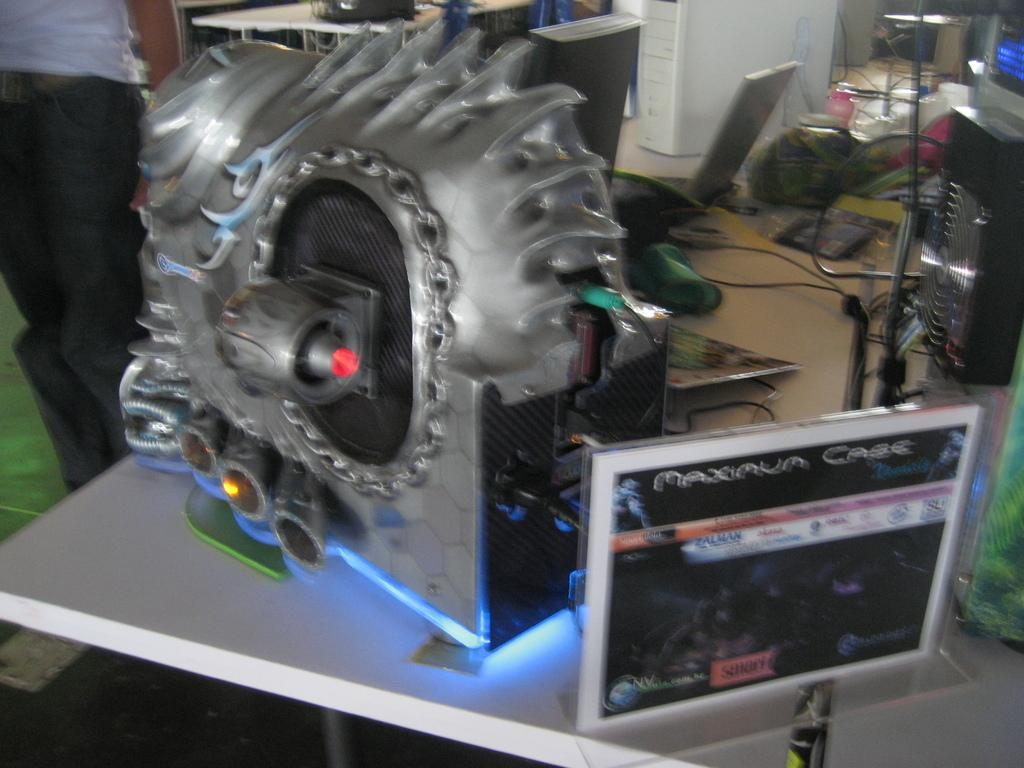What can be seen on the tables in the image? There are objects, devices, and wires on the tables in the image. What is visible beneath the tables in the image? The ground is visible in the image. Can you describe the person on the left side of the image? There is a person on the left side of the image, but no specific details about their appearance or actions are provided. What is featured on the poster in the image? The poster in the image has images and text. What type of thread is being used to copy the poster in the image? There is no thread or copying activity present in the image. The poster has images and text, but there is no indication that someone is trying to replicate it. 